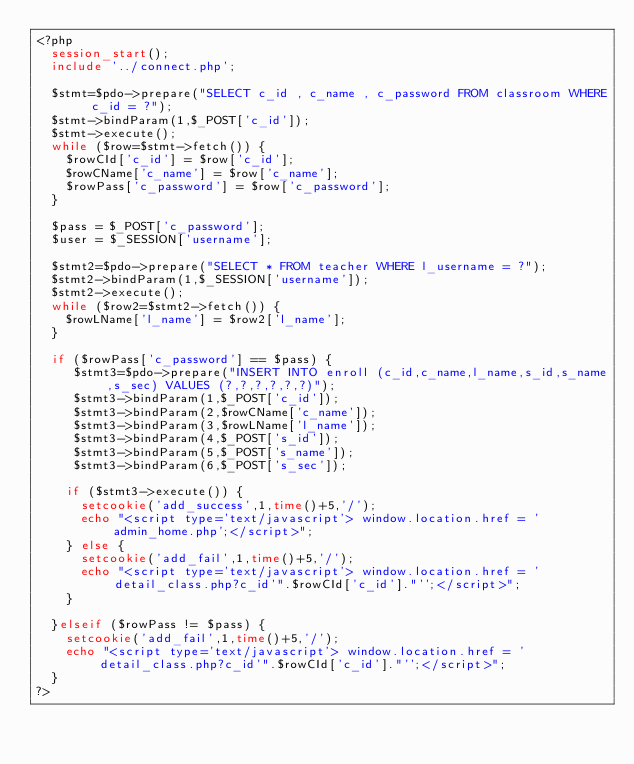Convert code to text. <code><loc_0><loc_0><loc_500><loc_500><_PHP_><?php 
	session_start();
	include '../connect.php';

	$stmt=$pdo->prepare("SELECT c_id , c_name , c_password FROM classroom WHERE c_id = ?");
	$stmt->bindParam(1,$_POST['c_id']);
	$stmt->execute();
	while ($row=$stmt->fetch()) {
		$rowCId['c_id'] = $row['c_id'];
		$rowCName['c_name'] = $row['c_name'];
		$rowPass['c_password'] = $row['c_password'];
	}

	$pass = $_POST['c_password'];
	$user = $_SESSION['username'];

	$stmt2=$pdo->prepare("SELECT * FROM teacher WHERE l_username = ?");
	$stmt2->bindParam(1,$_SESSION['username']);
	$stmt2->execute();
	while ($row2=$stmt2->fetch()) {
		$rowLName['l_name'] = $row2['l_name'];
	}

	if ($rowPass['c_password'] == $pass) {
		 $stmt3=$pdo->prepare("INSERT INTO enroll (c_id,c_name,l_name,s_id,s_name,s_sec) VALUES (?,?,?,?,?,?)");
		 $stmt3->bindParam(1,$_POST['c_id']);
		 $stmt3->bindParam(2,$rowCName['c_name']);
		 $stmt3->bindParam(3,$rowLName['l_name']);
		 $stmt3->bindParam(4,$_POST['s_id']);
		 $stmt3->bindParam(5,$_POST['s_name']);
		 $stmt3->bindParam(6,$_POST['s_sec']);

		if ($stmt3->execute()) {
			setcookie('add_success',1,time()+5,'/');
			echo "<script type='text/javascript'> window.location.href = 'admin_home.php';</script>";
		} else {
			setcookie('add_fail',1,time()+5,'/');
			echo "<script type='text/javascript'> window.location.href = 'detail_class.php?c_id'".$rowCId['c_id']."'';</script>";
		}

	}elseif ($rowPass != $pass) {
		setcookie('add_fail',1,time()+5,'/');
		echo "<script type='text/javascript'> window.location.href = 'detail_class.php?c_id'".$rowCId['c_id']."'';</script>";
	}
?></code> 